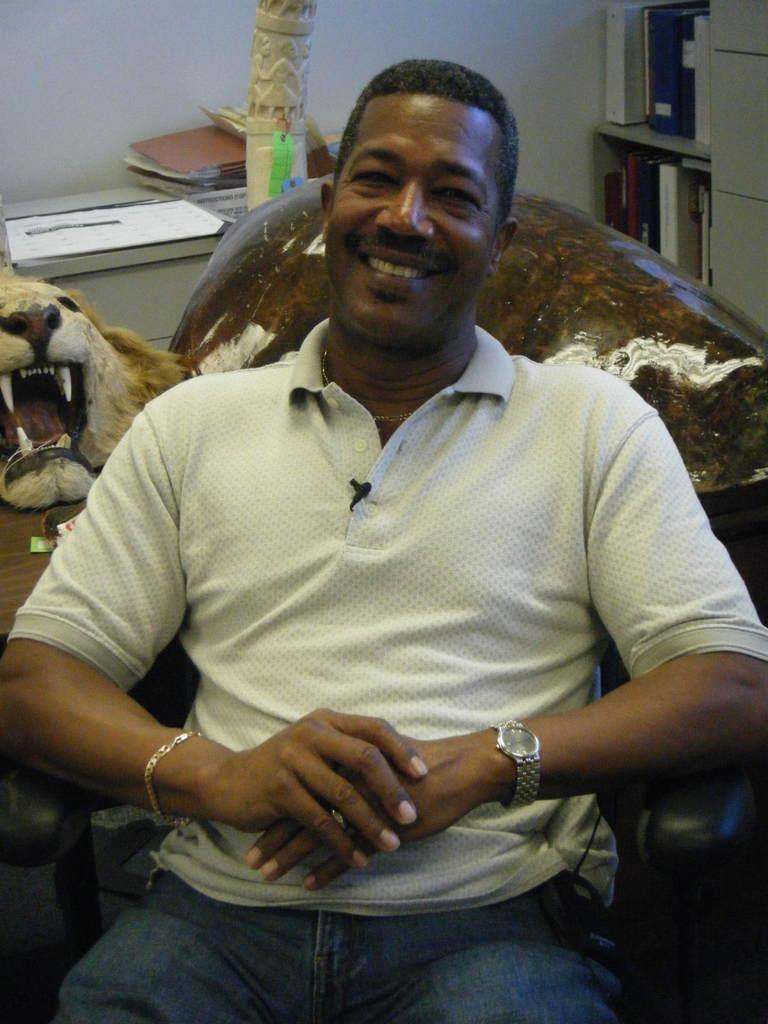Describe this image in one or two sentences. In this picture I can observe a man sitting in the chair. He is wearing white color T shirt. The man is smiling. On the left side I can observe the face of a lion placed on the table. In the background there is a wall. 